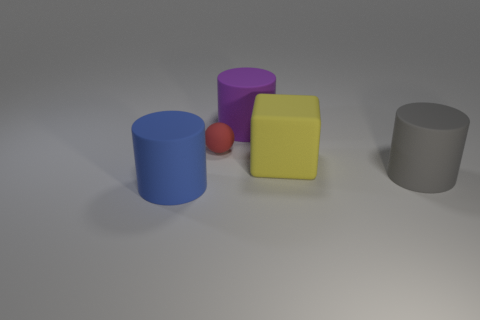What can you infer about the texture of the objects? The objects appear to have a matte texture with slight diffuse reflections, suggesting they might be made of a plastic or rubber-like material. 